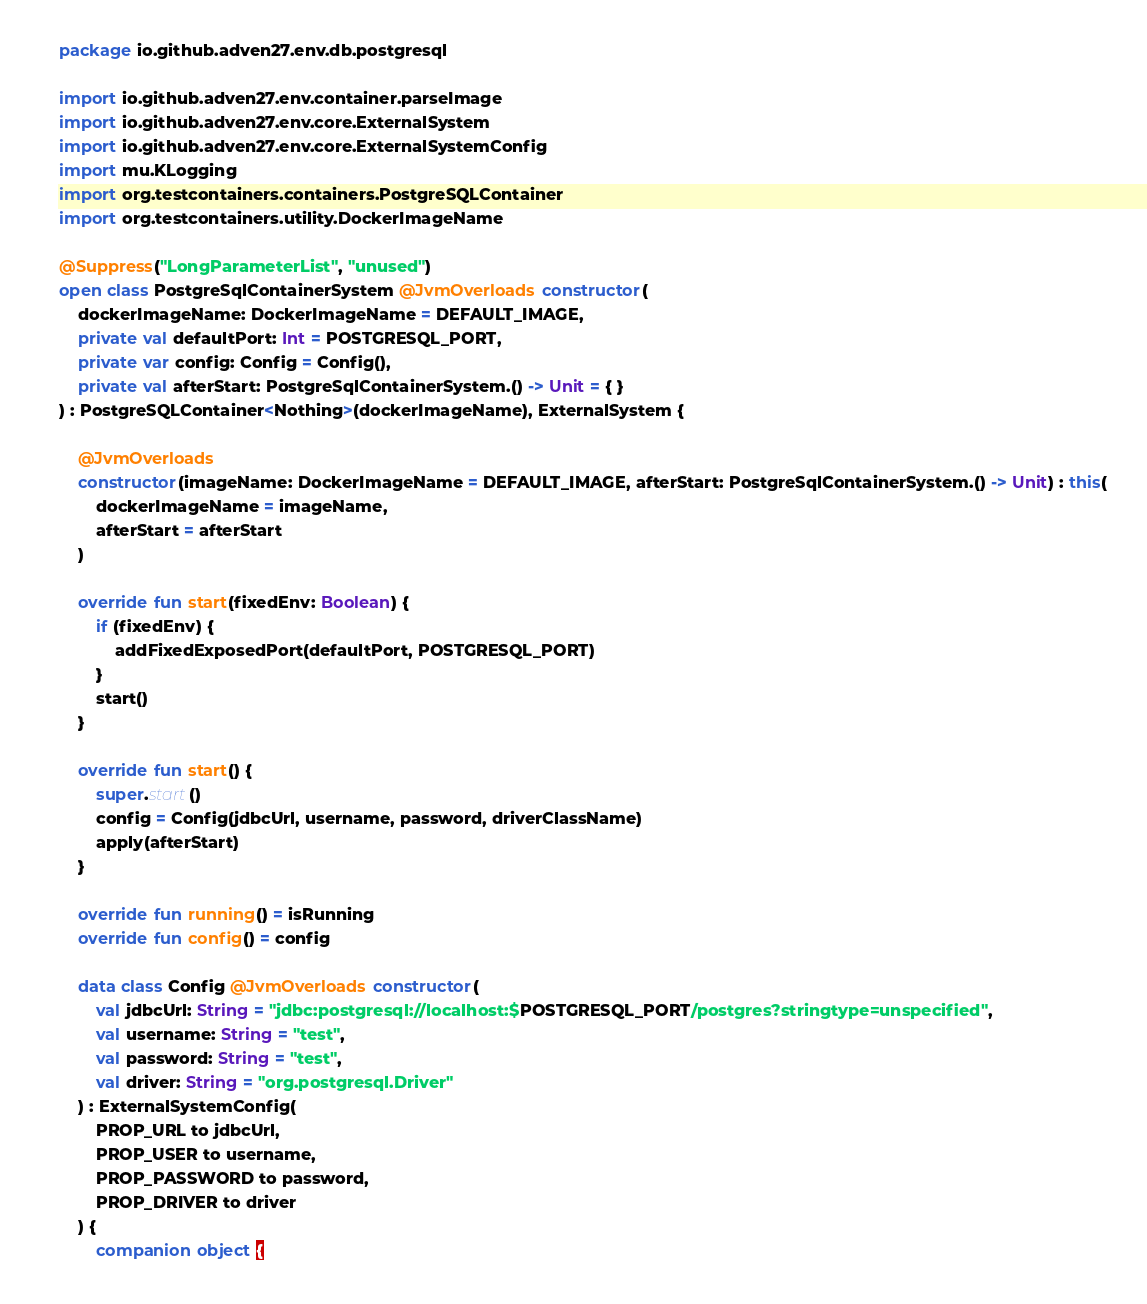Convert code to text. <code><loc_0><loc_0><loc_500><loc_500><_Kotlin_>package io.github.adven27.env.db.postgresql

import io.github.adven27.env.container.parseImage
import io.github.adven27.env.core.ExternalSystem
import io.github.adven27.env.core.ExternalSystemConfig
import mu.KLogging
import org.testcontainers.containers.PostgreSQLContainer
import org.testcontainers.utility.DockerImageName

@Suppress("LongParameterList", "unused")
open class PostgreSqlContainerSystem @JvmOverloads constructor(
    dockerImageName: DockerImageName = DEFAULT_IMAGE,
    private val defaultPort: Int = POSTGRESQL_PORT,
    private var config: Config = Config(),
    private val afterStart: PostgreSqlContainerSystem.() -> Unit = { }
) : PostgreSQLContainer<Nothing>(dockerImageName), ExternalSystem {

    @JvmOverloads
    constructor(imageName: DockerImageName = DEFAULT_IMAGE, afterStart: PostgreSqlContainerSystem.() -> Unit) : this(
        dockerImageName = imageName,
        afterStart = afterStart
    )

    override fun start(fixedEnv: Boolean) {
        if (fixedEnv) {
            addFixedExposedPort(defaultPort, POSTGRESQL_PORT)
        }
        start()
    }

    override fun start() {
        super.start()
        config = Config(jdbcUrl, username, password, driverClassName)
        apply(afterStart)
    }

    override fun running() = isRunning
    override fun config() = config

    data class Config @JvmOverloads constructor(
        val jdbcUrl: String = "jdbc:postgresql://localhost:$POSTGRESQL_PORT/postgres?stringtype=unspecified",
        val username: String = "test",
        val password: String = "test",
        val driver: String = "org.postgresql.Driver"
    ) : ExternalSystemConfig(
        PROP_URL to jdbcUrl,
        PROP_USER to username,
        PROP_PASSWORD to password,
        PROP_DRIVER to driver
    ) {
        companion object {</code> 